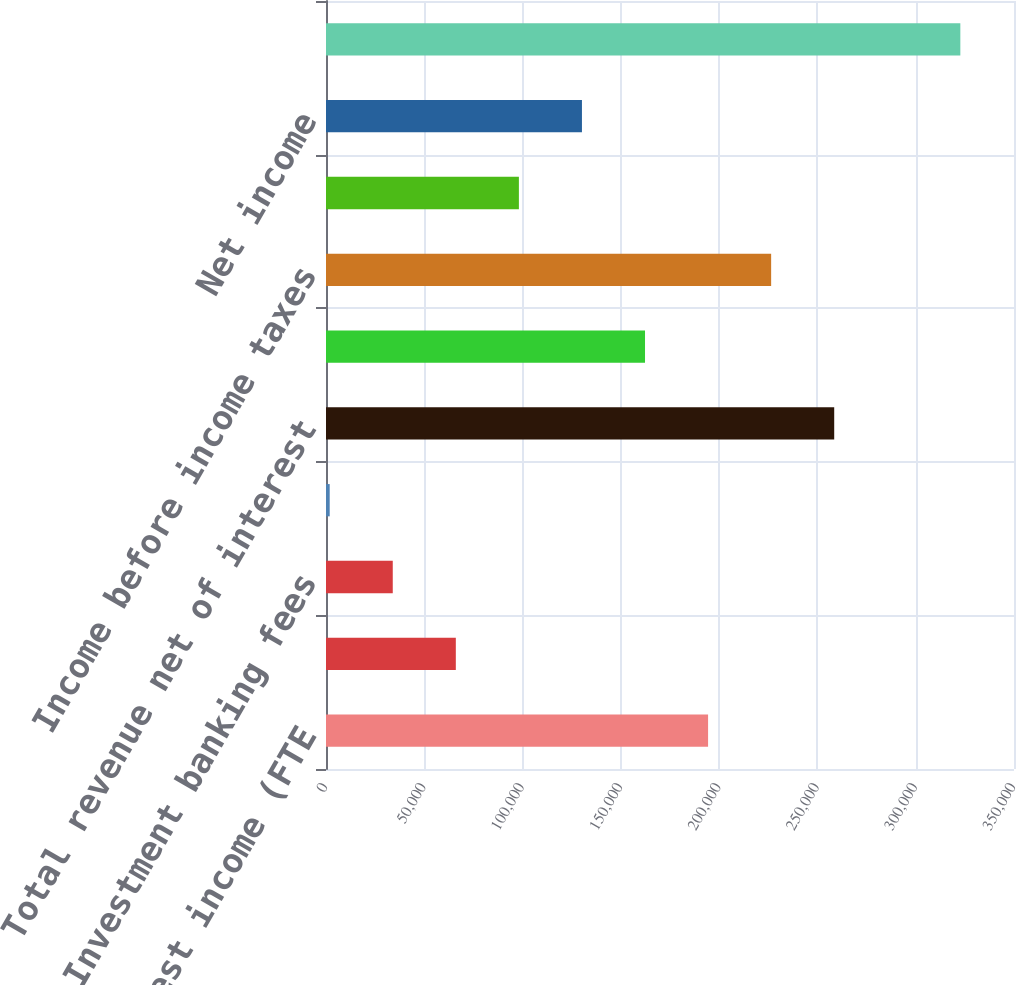<chart> <loc_0><loc_0><loc_500><loc_500><bar_chart><fcel>Net interest income (FTE<fcel>Service charges<fcel>Investment banking fees<fcel>All other income<fcel>Total revenue net of interest<fcel>Noninterest expense<fcel>Income before income taxes<fcel>Income tax expense (FTE basis)<fcel>Net income<fcel>Total loans and leases<nl><fcel>194372<fcel>66043.4<fcel>33961.2<fcel>1879<fcel>258537<fcel>162290<fcel>226454<fcel>98125.6<fcel>130208<fcel>322701<nl></chart> 